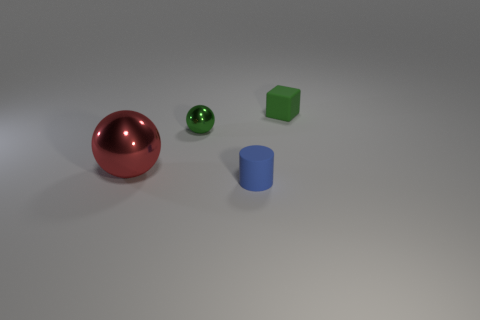Subtract 1 blocks. How many blocks are left? 0 Add 4 small blue shiny cylinders. How many objects exist? 8 Subtract all cylinders. How many objects are left? 3 Subtract all blue blocks. Subtract all blue spheres. How many blocks are left? 1 Subtract all red blocks. How many red spheres are left? 1 Subtract all small cyan blocks. Subtract all small spheres. How many objects are left? 3 Add 1 small spheres. How many small spheres are left? 2 Add 1 cubes. How many cubes exist? 2 Subtract 0 cyan cylinders. How many objects are left? 4 